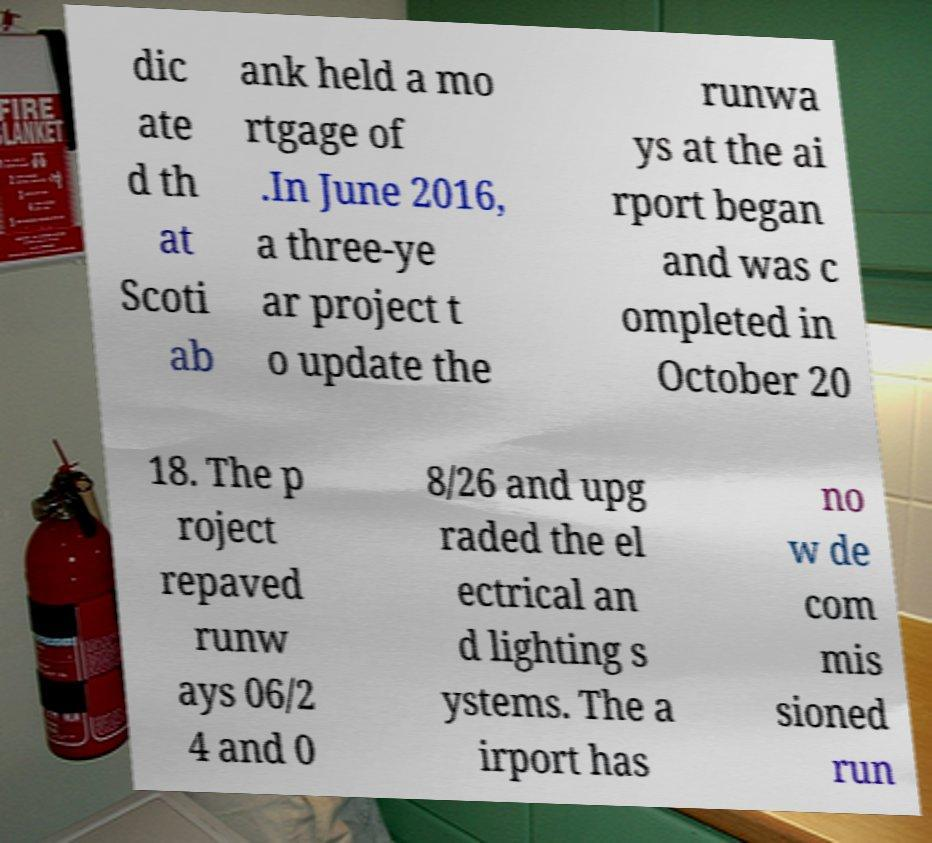What messages or text are displayed in this image? I need them in a readable, typed format. dic ate d th at Scoti ab ank held a mo rtgage of .In June 2016, a three-ye ar project t o update the runwa ys at the ai rport began and was c ompleted in October 20 18. The p roject repaved runw ays 06/2 4 and 0 8/26 and upg raded the el ectrical an d lighting s ystems. The a irport has no w de com mis sioned run 